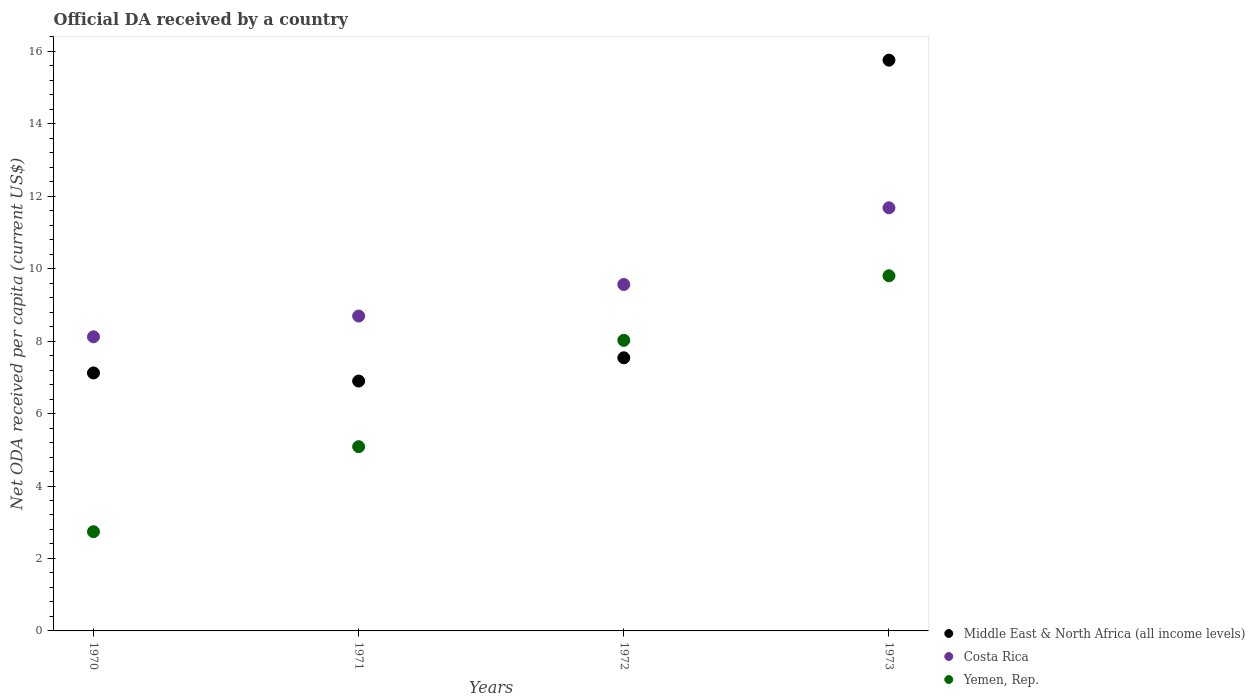What is the ODA received in in Middle East & North Africa (all income levels) in 1970?
Keep it short and to the point. 7.12. Across all years, what is the maximum ODA received in in Costa Rica?
Your response must be concise. 11.68. Across all years, what is the minimum ODA received in in Yemen, Rep.?
Your response must be concise. 2.74. What is the total ODA received in in Costa Rica in the graph?
Provide a short and direct response. 38.05. What is the difference between the ODA received in in Yemen, Rep. in 1971 and that in 1973?
Ensure brevity in your answer.  -4.72. What is the difference between the ODA received in in Yemen, Rep. in 1971 and the ODA received in in Costa Rica in 1972?
Your answer should be very brief. -4.48. What is the average ODA received in in Costa Rica per year?
Provide a short and direct response. 9.51. In the year 1970, what is the difference between the ODA received in in Middle East & North Africa (all income levels) and ODA received in in Yemen, Rep.?
Give a very brief answer. 4.38. What is the ratio of the ODA received in in Yemen, Rep. in 1971 to that in 1972?
Ensure brevity in your answer.  0.63. Is the ODA received in in Costa Rica in 1972 less than that in 1973?
Make the answer very short. Yes. What is the difference between the highest and the second highest ODA received in in Costa Rica?
Your response must be concise. 2.12. What is the difference between the highest and the lowest ODA received in in Yemen, Rep.?
Ensure brevity in your answer.  7.06. In how many years, is the ODA received in in Costa Rica greater than the average ODA received in in Costa Rica taken over all years?
Offer a very short reply. 2. Does the ODA received in in Yemen, Rep. monotonically increase over the years?
Your answer should be very brief. Yes. Is the ODA received in in Yemen, Rep. strictly less than the ODA received in in Costa Rica over the years?
Your answer should be very brief. Yes. What is the difference between two consecutive major ticks on the Y-axis?
Give a very brief answer. 2. Are the values on the major ticks of Y-axis written in scientific E-notation?
Make the answer very short. No. Does the graph contain any zero values?
Give a very brief answer. No. Does the graph contain grids?
Offer a terse response. No. Where does the legend appear in the graph?
Your response must be concise. Bottom right. What is the title of the graph?
Your response must be concise. Official DA received by a country. What is the label or title of the Y-axis?
Your answer should be very brief. Net ODA received per capita (current US$). What is the Net ODA received per capita (current US$) in Middle East & North Africa (all income levels) in 1970?
Provide a succinct answer. 7.12. What is the Net ODA received per capita (current US$) in Costa Rica in 1970?
Keep it short and to the point. 8.12. What is the Net ODA received per capita (current US$) in Yemen, Rep. in 1970?
Ensure brevity in your answer.  2.74. What is the Net ODA received per capita (current US$) in Middle East & North Africa (all income levels) in 1971?
Your answer should be very brief. 6.9. What is the Net ODA received per capita (current US$) of Costa Rica in 1971?
Your answer should be very brief. 8.69. What is the Net ODA received per capita (current US$) of Yemen, Rep. in 1971?
Make the answer very short. 5.09. What is the Net ODA received per capita (current US$) in Middle East & North Africa (all income levels) in 1972?
Ensure brevity in your answer.  7.54. What is the Net ODA received per capita (current US$) in Costa Rica in 1972?
Keep it short and to the point. 9.56. What is the Net ODA received per capita (current US$) of Yemen, Rep. in 1972?
Offer a very short reply. 8.02. What is the Net ODA received per capita (current US$) in Middle East & North Africa (all income levels) in 1973?
Offer a very short reply. 15.76. What is the Net ODA received per capita (current US$) of Costa Rica in 1973?
Provide a short and direct response. 11.68. What is the Net ODA received per capita (current US$) of Yemen, Rep. in 1973?
Your response must be concise. 9.8. Across all years, what is the maximum Net ODA received per capita (current US$) in Middle East & North Africa (all income levels)?
Provide a succinct answer. 15.76. Across all years, what is the maximum Net ODA received per capita (current US$) in Costa Rica?
Your answer should be very brief. 11.68. Across all years, what is the maximum Net ODA received per capita (current US$) in Yemen, Rep.?
Provide a short and direct response. 9.8. Across all years, what is the minimum Net ODA received per capita (current US$) of Middle East & North Africa (all income levels)?
Provide a succinct answer. 6.9. Across all years, what is the minimum Net ODA received per capita (current US$) in Costa Rica?
Ensure brevity in your answer.  8.12. Across all years, what is the minimum Net ODA received per capita (current US$) of Yemen, Rep.?
Your answer should be compact. 2.74. What is the total Net ODA received per capita (current US$) in Middle East & North Africa (all income levels) in the graph?
Offer a very short reply. 37.31. What is the total Net ODA received per capita (current US$) of Costa Rica in the graph?
Provide a short and direct response. 38.05. What is the total Net ODA received per capita (current US$) in Yemen, Rep. in the graph?
Provide a succinct answer. 25.65. What is the difference between the Net ODA received per capita (current US$) in Middle East & North Africa (all income levels) in 1970 and that in 1971?
Provide a succinct answer. 0.22. What is the difference between the Net ODA received per capita (current US$) in Costa Rica in 1970 and that in 1971?
Give a very brief answer. -0.57. What is the difference between the Net ODA received per capita (current US$) in Yemen, Rep. in 1970 and that in 1971?
Give a very brief answer. -2.35. What is the difference between the Net ODA received per capita (current US$) in Middle East & North Africa (all income levels) in 1970 and that in 1972?
Your answer should be very brief. -0.42. What is the difference between the Net ODA received per capita (current US$) of Costa Rica in 1970 and that in 1972?
Offer a terse response. -1.44. What is the difference between the Net ODA received per capita (current US$) in Yemen, Rep. in 1970 and that in 1972?
Offer a terse response. -5.28. What is the difference between the Net ODA received per capita (current US$) in Middle East & North Africa (all income levels) in 1970 and that in 1973?
Give a very brief answer. -8.63. What is the difference between the Net ODA received per capita (current US$) in Costa Rica in 1970 and that in 1973?
Provide a short and direct response. -3.56. What is the difference between the Net ODA received per capita (current US$) in Yemen, Rep. in 1970 and that in 1973?
Keep it short and to the point. -7.06. What is the difference between the Net ODA received per capita (current US$) in Middle East & North Africa (all income levels) in 1971 and that in 1972?
Offer a very short reply. -0.64. What is the difference between the Net ODA received per capita (current US$) of Costa Rica in 1971 and that in 1972?
Give a very brief answer. -0.87. What is the difference between the Net ODA received per capita (current US$) of Yemen, Rep. in 1971 and that in 1972?
Offer a terse response. -2.94. What is the difference between the Net ODA received per capita (current US$) of Middle East & North Africa (all income levels) in 1971 and that in 1973?
Ensure brevity in your answer.  -8.86. What is the difference between the Net ODA received per capita (current US$) in Costa Rica in 1971 and that in 1973?
Offer a very short reply. -2.99. What is the difference between the Net ODA received per capita (current US$) in Yemen, Rep. in 1971 and that in 1973?
Provide a short and direct response. -4.72. What is the difference between the Net ODA received per capita (current US$) of Middle East & North Africa (all income levels) in 1972 and that in 1973?
Your response must be concise. -8.22. What is the difference between the Net ODA received per capita (current US$) of Costa Rica in 1972 and that in 1973?
Provide a succinct answer. -2.12. What is the difference between the Net ODA received per capita (current US$) in Yemen, Rep. in 1972 and that in 1973?
Provide a short and direct response. -1.78. What is the difference between the Net ODA received per capita (current US$) in Middle East & North Africa (all income levels) in 1970 and the Net ODA received per capita (current US$) in Costa Rica in 1971?
Give a very brief answer. -1.57. What is the difference between the Net ODA received per capita (current US$) of Middle East & North Africa (all income levels) in 1970 and the Net ODA received per capita (current US$) of Yemen, Rep. in 1971?
Provide a succinct answer. 2.04. What is the difference between the Net ODA received per capita (current US$) of Costa Rica in 1970 and the Net ODA received per capita (current US$) of Yemen, Rep. in 1971?
Your answer should be compact. 3.03. What is the difference between the Net ODA received per capita (current US$) of Middle East & North Africa (all income levels) in 1970 and the Net ODA received per capita (current US$) of Costa Rica in 1972?
Ensure brevity in your answer.  -2.44. What is the difference between the Net ODA received per capita (current US$) in Middle East & North Africa (all income levels) in 1970 and the Net ODA received per capita (current US$) in Yemen, Rep. in 1972?
Your answer should be compact. -0.9. What is the difference between the Net ODA received per capita (current US$) in Costa Rica in 1970 and the Net ODA received per capita (current US$) in Yemen, Rep. in 1972?
Offer a very short reply. 0.1. What is the difference between the Net ODA received per capita (current US$) of Middle East & North Africa (all income levels) in 1970 and the Net ODA received per capita (current US$) of Costa Rica in 1973?
Provide a succinct answer. -4.56. What is the difference between the Net ODA received per capita (current US$) in Middle East & North Africa (all income levels) in 1970 and the Net ODA received per capita (current US$) in Yemen, Rep. in 1973?
Offer a terse response. -2.68. What is the difference between the Net ODA received per capita (current US$) of Costa Rica in 1970 and the Net ODA received per capita (current US$) of Yemen, Rep. in 1973?
Your answer should be compact. -1.68. What is the difference between the Net ODA received per capita (current US$) in Middle East & North Africa (all income levels) in 1971 and the Net ODA received per capita (current US$) in Costa Rica in 1972?
Provide a succinct answer. -2.67. What is the difference between the Net ODA received per capita (current US$) of Middle East & North Africa (all income levels) in 1971 and the Net ODA received per capita (current US$) of Yemen, Rep. in 1972?
Give a very brief answer. -1.12. What is the difference between the Net ODA received per capita (current US$) in Costa Rica in 1971 and the Net ODA received per capita (current US$) in Yemen, Rep. in 1972?
Offer a very short reply. 0.67. What is the difference between the Net ODA received per capita (current US$) of Middle East & North Africa (all income levels) in 1971 and the Net ODA received per capita (current US$) of Costa Rica in 1973?
Your answer should be very brief. -4.78. What is the difference between the Net ODA received per capita (current US$) of Middle East & North Africa (all income levels) in 1971 and the Net ODA received per capita (current US$) of Yemen, Rep. in 1973?
Your answer should be very brief. -2.91. What is the difference between the Net ODA received per capita (current US$) of Costa Rica in 1971 and the Net ODA received per capita (current US$) of Yemen, Rep. in 1973?
Your response must be concise. -1.11. What is the difference between the Net ODA received per capita (current US$) in Middle East & North Africa (all income levels) in 1972 and the Net ODA received per capita (current US$) in Costa Rica in 1973?
Your answer should be very brief. -4.14. What is the difference between the Net ODA received per capita (current US$) of Middle East & North Africa (all income levels) in 1972 and the Net ODA received per capita (current US$) of Yemen, Rep. in 1973?
Your response must be concise. -2.26. What is the difference between the Net ODA received per capita (current US$) in Costa Rica in 1972 and the Net ODA received per capita (current US$) in Yemen, Rep. in 1973?
Your response must be concise. -0.24. What is the average Net ODA received per capita (current US$) in Middle East & North Africa (all income levels) per year?
Make the answer very short. 9.33. What is the average Net ODA received per capita (current US$) in Costa Rica per year?
Your response must be concise. 9.51. What is the average Net ODA received per capita (current US$) in Yemen, Rep. per year?
Provide a short and direct response. 6.41. In the year 1970, what is the difference between the Net ODA received per capita (current US$) of Middle East & North Africa (all income levels) and Net ODA received per capita (current US$) of Costa Rica?
Provide a succinct answer. -1. In the year 1970, what is the difference between the Net ODA received per capita (current US$) of Middle East & North Africa (all income levels) and Net ODA received per capita (current US$) of Yemen, Rep.?
Provide a short and direct response. 4.38. In the year 1970, what is the difference between the Net ODA received per capita (current US$) of Costa Rica and Net ODA received per capita (current US$) of Yemen, Rep.?
Your answer should be compact. 5.38. In the year 1971, what is the difference between the Net ODA received per capita (current US$) of Middle East & North Africa (all income levels) and Net ODA received per capita (current US$) of Costa Rica?
Make the answer very short. -1.79. In the year 1971, what is the difference between the Net ODA received per capita (current US$) in Middle East & North Africa (all income levels) and Net ODA received per capita (current US$) in Yemen, Rep.?
Offer a terse response. 1.81. In the year 1971, what is the difference between the Net ODA received per capita (current US$) in Costa Rica and Net ODA received per capita (current US$) in Yemen, Rep.?
Offer a terse response. 3.61. In the year 1972, what is the difference between the Net ODA received per capita (current US$) in Middle East & North Africa (all income levels) and Net ODA received per capita (current US$) in Costa Rica?
Your answer should be compact. -2.02. In the year 1972, what is the difference between the Net ODA received per capita (current US$) of Middle East & North Africa (all income levels) and Net ODA received per capita (current US$) of Yemen, Rep.?
Make the answer very short. -0.48. In the year 1972, what is the difference between the Net ODA received per capita (current US$) in Costa Rica and Net ODA received per capita (current US$) in Yemen, Rep.?
Keep it short and to the point. 1.54. In the year 1973, what is the difference between the Net ODA received per capita (current US$) of Middle East & North Africa (all income levels) and Net ODA received per capita (current US$) of Costa Rica?
Make the answer very short. 4.08. In the year 1973, what is the difference between the Net ODA received per capita (current US$) in Middle East & North Africa (all income levels) and Net ODA received per capita (current US$) in Yemen, Rep.?
Your answer should be compact. 5.95. In the year 1973, what is the difference between the Net ODA received per capita (current US$) of Costa Rica and Net ODA received per capita (current US$) of Yemen, Rep.?
Ensure brevity in your answer.  1.88. What is the ratio of the Net ODA received per capita (current US$) of Middle East & North Africa (all income levels) in 1970 to that in 1971?
Your answer should be very brief. 1.03. What is the ratio of the Net ODA received per capita (current US$) in Costa Rica in 1970 to that in 1971?
Provide a succinct answer. 0.93. What is the ratio of the Net ODA received per capita (current US$) of Yemen, Rep. in 1970 to that in 1971?
Your answer should be very brief. 0.54. What is the ratio of the Net ODA received per capita (current US$) in Middle East & North Africa (all income levels) in 1970 to that in 1972?
Ensure brevity in your answer.  0.94. What is the ratio of the Net ODA received per capita (current US$) of Costa Rica in 1970 to that in 1972?
Offer a very short reply. 0.85. What is the ratio of the Net ODA received per capita (current US$) of Yemen, Rep. in 1970 to that in 1972?
Give a very brief answer. 0.34. What is the ratio of the Net ODA received per capita (current US$) in Middle East & North Africa (all income levels) in 1970 to that in 1973?
Keep it short and to the point. 0.45. What is the ratio of the Net ODA received per capita (current US$) of Costa Rica in 1970 to that in 1973?
Your response must be concise. 0.7. What is the ratio of the Net ODA received per capita (current US$) of Yemen, Rep. in 1970 to that in 1973?
Your answer should be compact. 0.28. What is the ratio of the Net ODA received per capita (current US$) of Middle East & North Africa (all income levels) in 1971 to that in 1972?
Offer a very short reply. 0.91. What is the ratio of the Net ODA received per capita (current US$) of Costa Rica in 1971 to that in 1972?
Offer a very short reply. 0.91. What is the ratio of the Net ODA received per capita (current US$) of Yemen, Rep. in 1971 to that in 1972?
Keep it short and to the point. 0.63. What is the ratio of the Net ODA received per capita (current US$) in Middle East & North Africa (all income levels) in 1971 to that in 1973?
Provide a short and direct response. 0.44. What is the ratio of the Net ODA received per capita (current US$) in Costa Rica in 1971 to that in 1973?
Offer a very short reply. 0.74. What is the ratio of the Net ODA received per capita (current US$) in Yemen, Rep. in 1971 to that in 1973?
Give a very brief answer. 0.52. What is the ratio of the Net ODA received per capita (current US$) of Middle East & North Africa (all income levels) in 1972 to that in 1973?
Your answer should be compact. 0.48. What is the ratio of the Net ODA received per capita (current US$) of Costa Rica in 1972 to that in 1973?
Your answer should be compact. 0.82. What is the ratio of the Net ODA received per capita (current US$) of Yemen, Rep. in 1972 to that in 1973?
Provide a succinct answer. 0.82. What is the difference between the highest and the second highest Net ODA received per capita (current US$) of Middle East & North Africa (all income levels)?
Make the answer very short. 8.22. What is the difference between the highest and the second highest Net ODA received per capita (current US$) of Costa Rica?
Make the answer very short. 2.12. What is the difference between the highest and the second highest Net ODA received per capita (current US$) of Yemen, Rep.?
Offer a very short reply. 1.78. What is the difference between the highest and the lowest Net ODA received per capita (current US$) in Middle East & North Africa (all income levels)?
Provide a succinct answer. 8.86. What is the difference between the highest and the lowest Net ODA received per capita (current US$) of Costa Rica?
Your response must be concise. 3.56. What is the difference between the highest and the lowest Net ODA received per capita (current US$) in Yemen, Rep.?
Offer a very short reply. 7.06. 